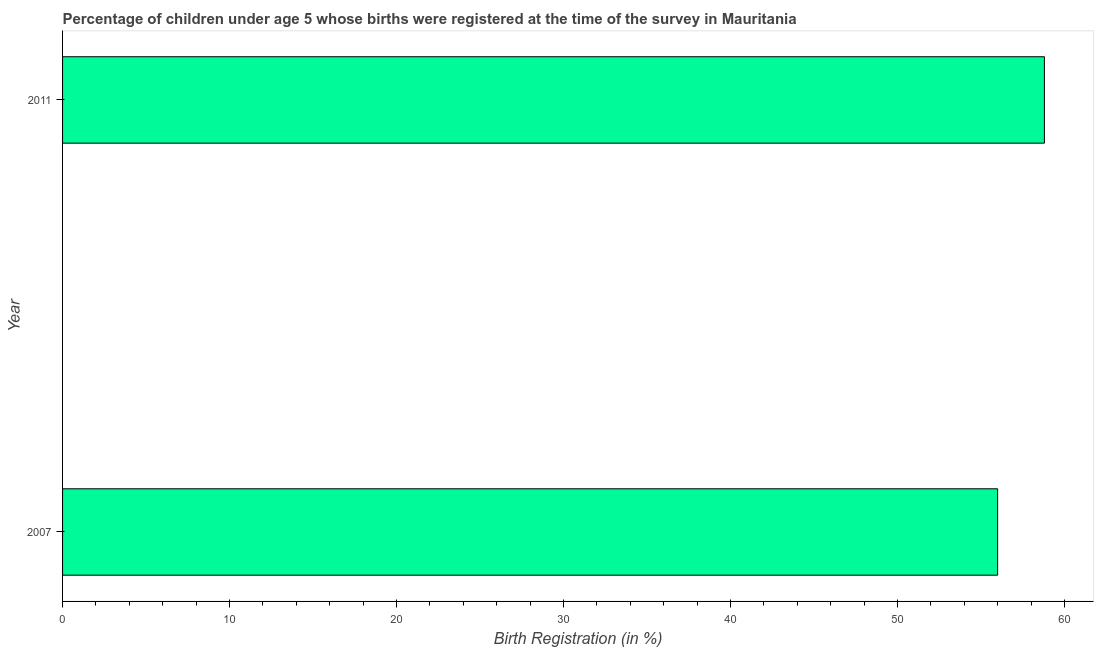Does the graph contain grids?
Offer a terse response. No. What is the title of the graph?
Provide a succinct answer. Percentage of children under age 5 whose births were registered at the time of the survey in Mauritania. What is the label or title of the X-axis?
Your answer should be compact. Birth Registration (in %). What is the birth registration in 2011?
Provide a succinct answer. 58.8. Across all years, what is the maximum birth registration?
Provide a short and direct response. 58.8. Across all years, what is the minimum birth registration?
Your answer should be compact. 56. In which year was the birth registration maximum?
Your answer should be compact. 2011. What is the sum of the birth registration?
Give a very brief answer. 114.8. What is the difference between the birth registration in 2007 and 2011?
Keep it short and to the point. -2.8. What is the average birth registration per year?
Ensure brevity in your answer.  57.4. What is the median birth registration?
Offer a terse response. 57.4. Do a majority of the years between 2011 and 2007 (inclusive) have birth registration greater than 30 %?
Keep it short and to the point. No. What is the ratio of the birth registration in 2007 to that in 2011?
Give a very brief answer. 0.95. How many bars are there?
Make the answer very short. 2. Are all the bars in the graph horizontal?
Provide a succinct answer. Yes. What is the difference between two consecutive major ticks on the X-axis?
Make the answer very short. 10. What is the Birth Registration (in %) of 2007?
Your answer should be compact. 56. What is the Birth Registration (in %) of 2011?
Keep it short and to the point. 58.8. What is the difference between the Birth Registration (in %) in 2007 and 2011?
Offer a terse response. -2.8. 